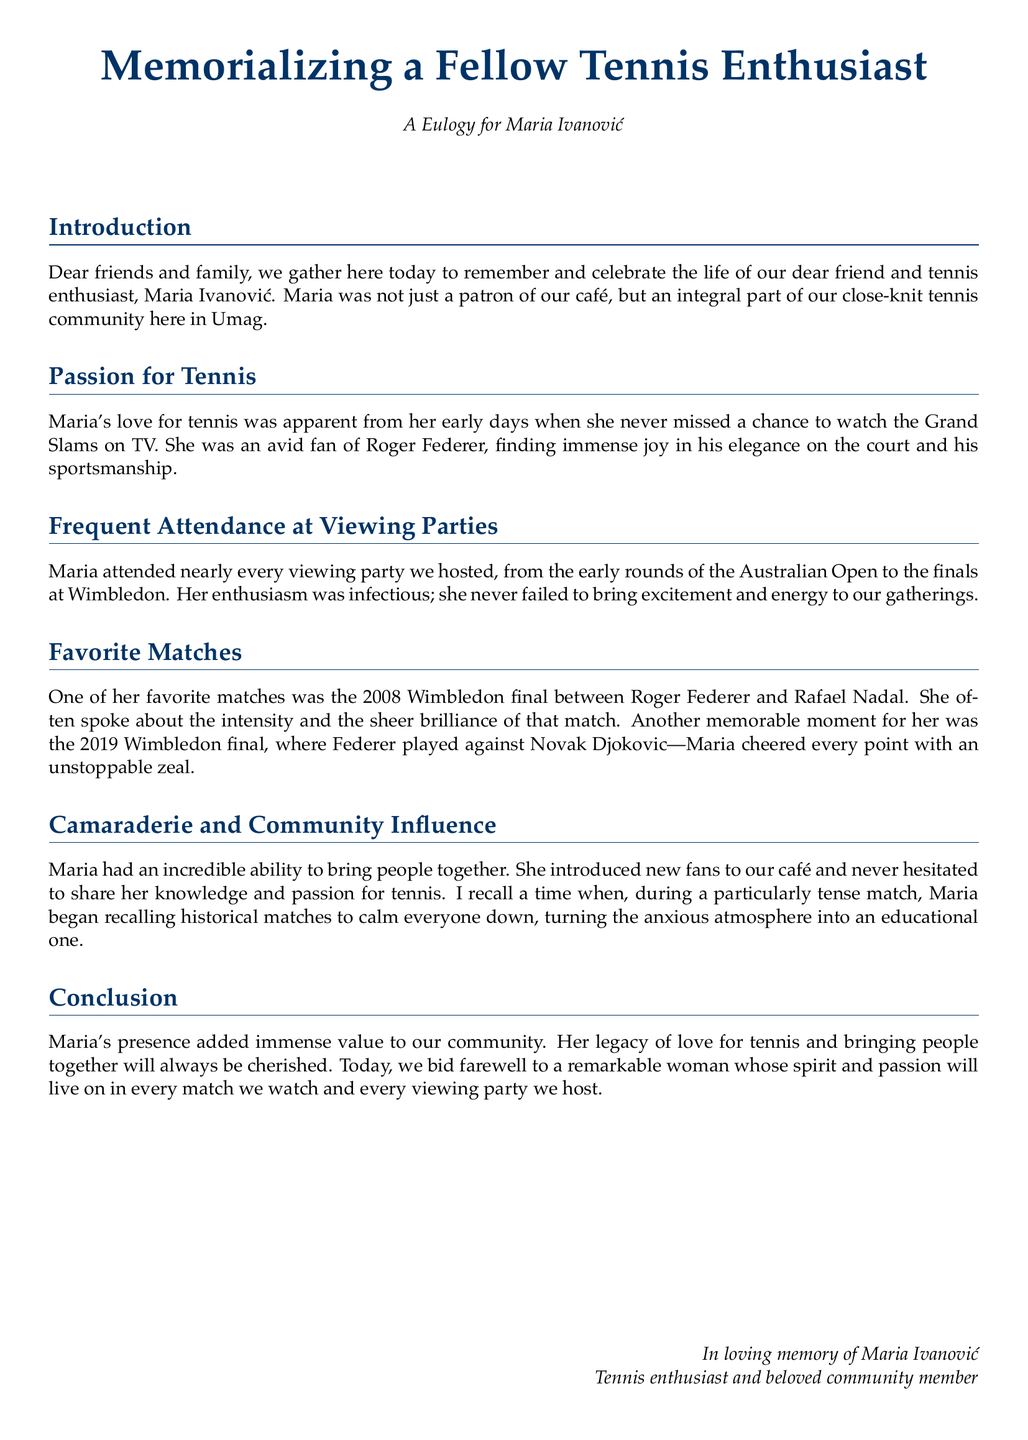What was Maria Ivanović's favorite player? The document states that Maria was an avid fan of Roger Federer.
Answer: Roger Federer Which significant tennis event did Maria never miss? It is mentioned that she never missed a chance to watch the Grand Slams on TV.
Answer: Grand Slams What were the years of the Wimbledon finals mentioned? The eulogy specifically references the 2008 and 2019 Wimbledon finals.
Answer: 2008 and 2019 What characteristic of Maria's presence is highlighted in the document? The document notes Maria's incredible ability to bring people together.
Answer: Bringing people together How did Maria help during a tense match? The document recalls a time when she began recalling historical matches to calm everyone down.
Answer: Reciting historical matches 